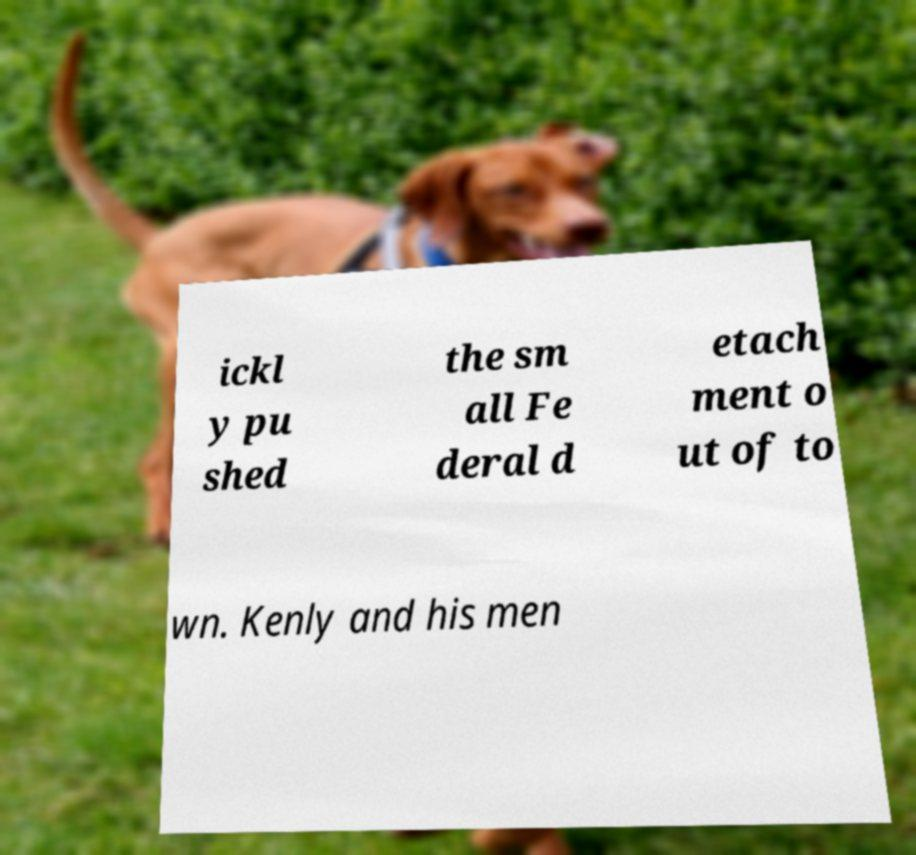There's text embedded in this image that I need extracted. Can you transcribe it verbatim? ickl y pu shed the sm all Fe deral d etach ment o ut of to wn. Kenly and his men 